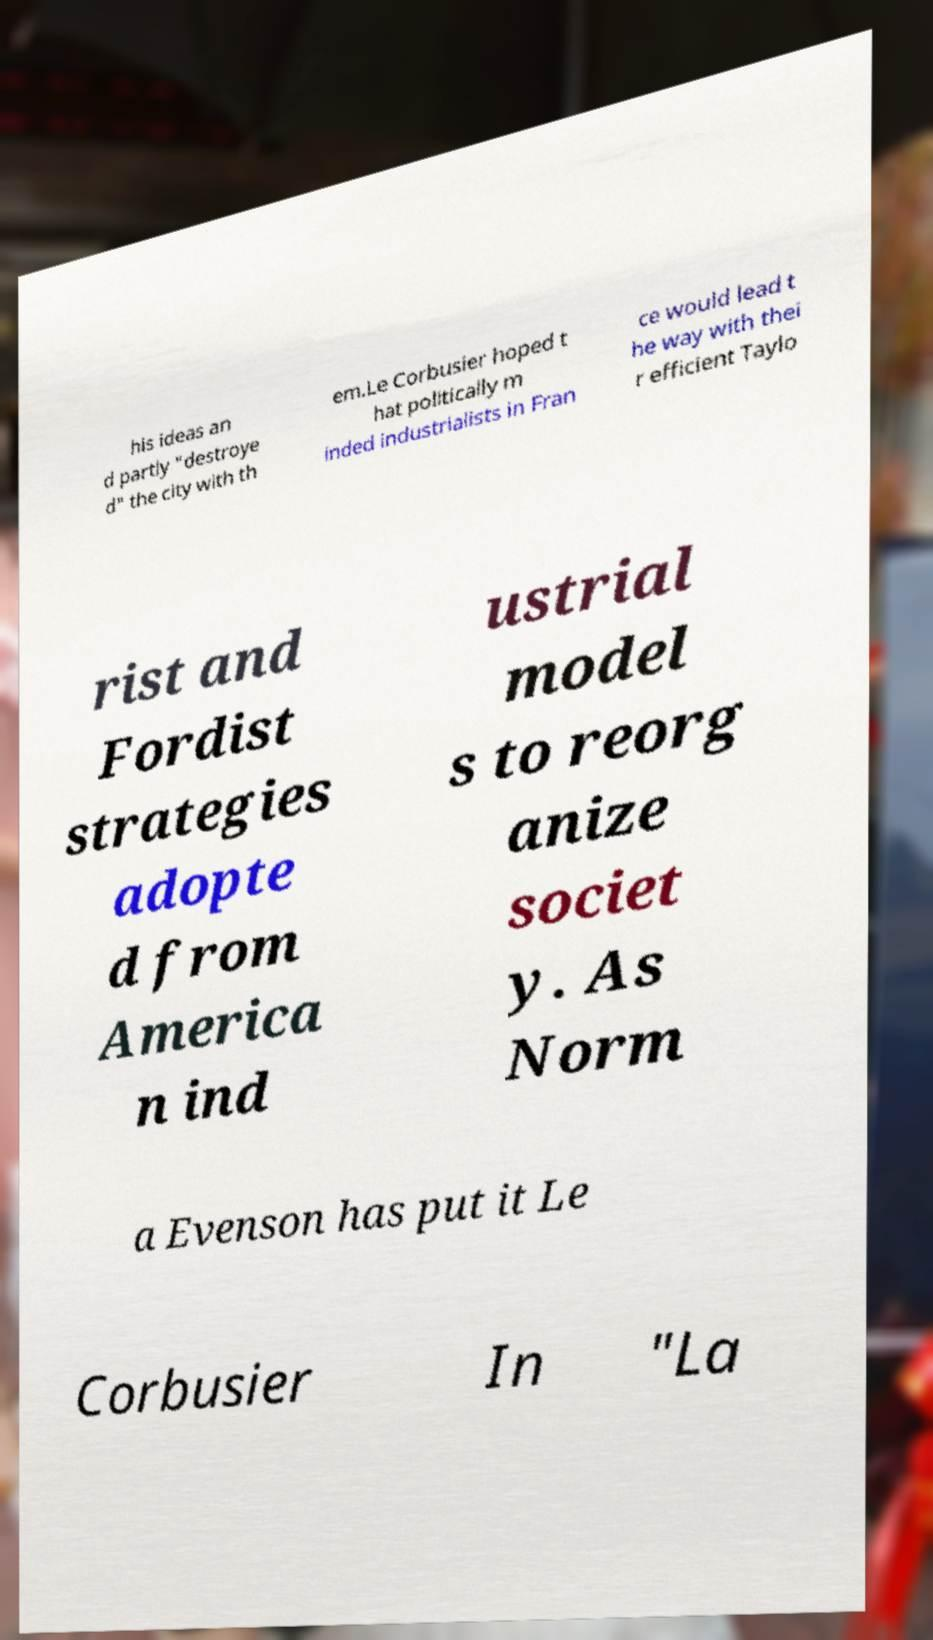Can you read and provide the text displayed in the image?This photo seems to have some interesting text. Can you extract and type it out for me? his ideas an d partly "destroye d" the city with th em.Le Corbusier hoped t hat politically m inded industrialists in Fran ce would lead t he way with thei r efficient Taylo rist and Fordist strategies adopte d from America n ind ustrial model s to reorg anize societ y. As Norm a Evenson has put it Le Corbusier In "La 